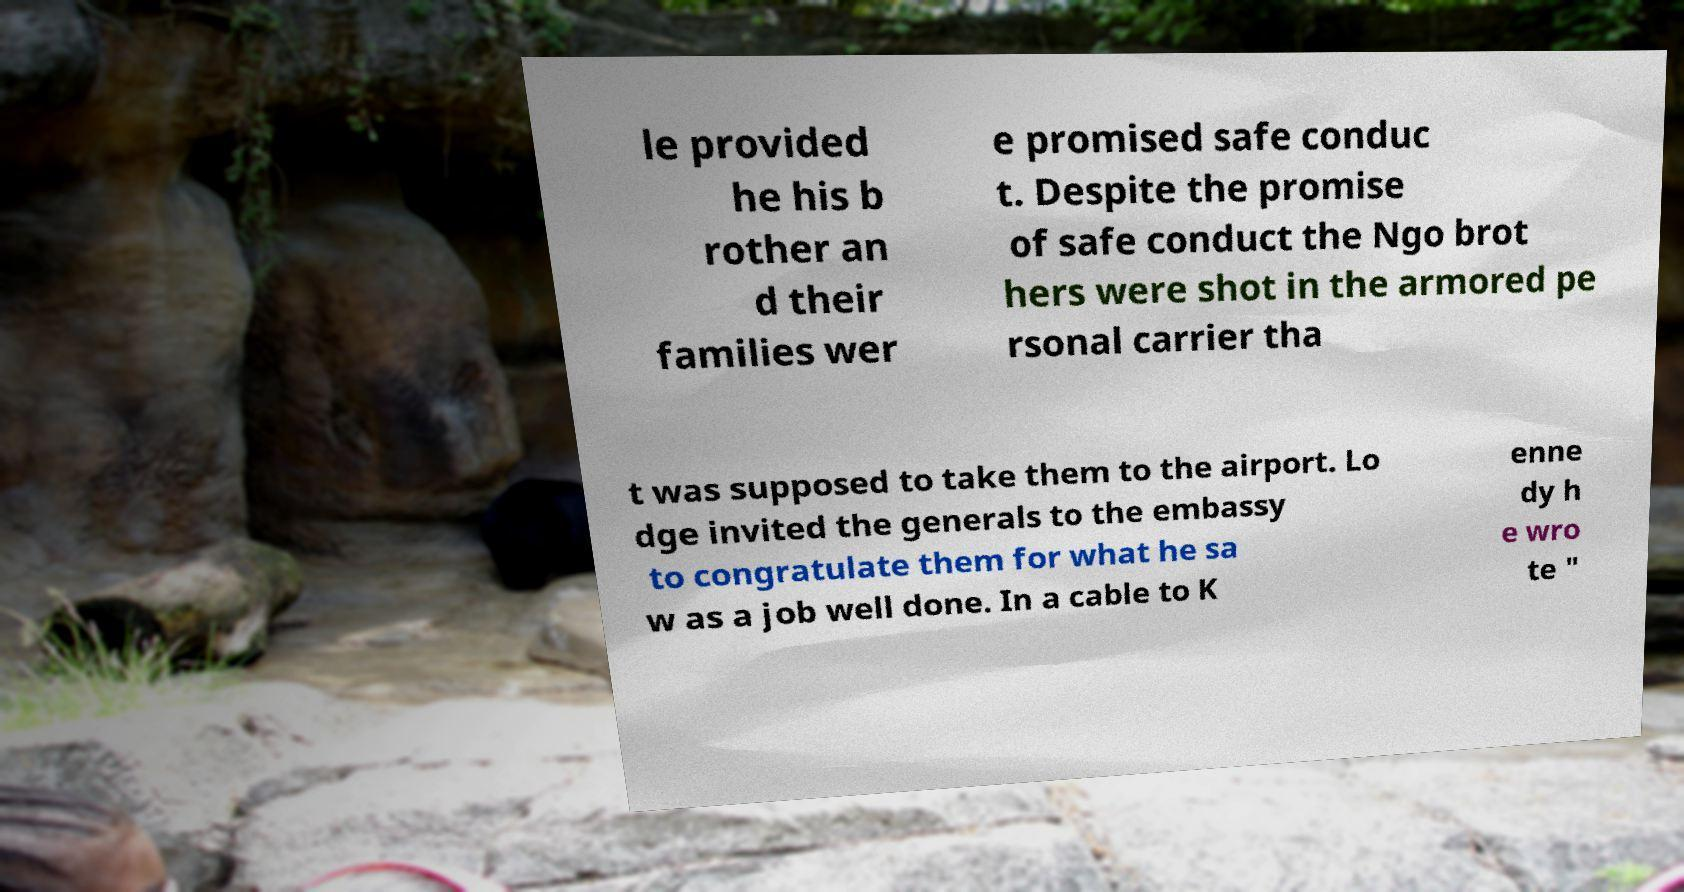Could you extract and type out the text from this image? le provided he his b rother an d their families wer e promised safe conduc t. Despite the promise of safe conduct the Ngo brot hers were shot in the armored pe rsonal carrier tha t was supposed to take them to the airport. Lo dge invited the generals to the embassy to congratulate them for what he sa w as a job well done. In a cable to K enne dy h e wro te " 